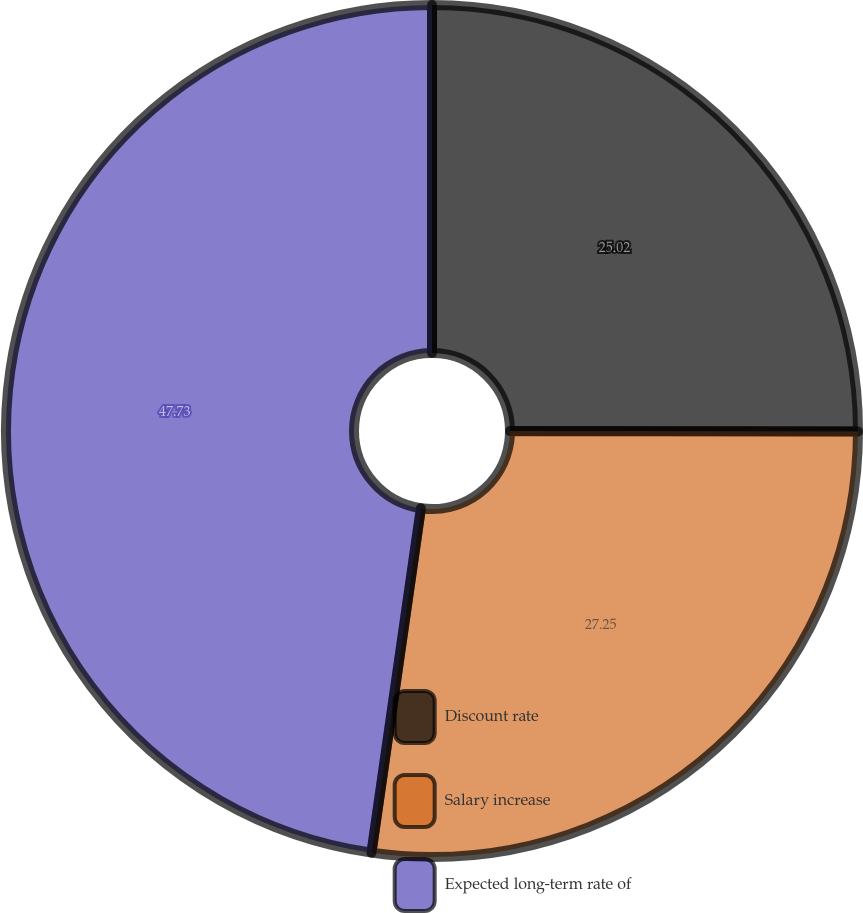Convert chart. <chart><loc_0><loc_0><loc_500><loc_500><pie_chart><fcel>Discount rate<fcel>Salary increase<fcel>Expected long-term rate of<nl><fcel>25.02%<fcel>27.25%<fcel>47.73%<nl></chart> 